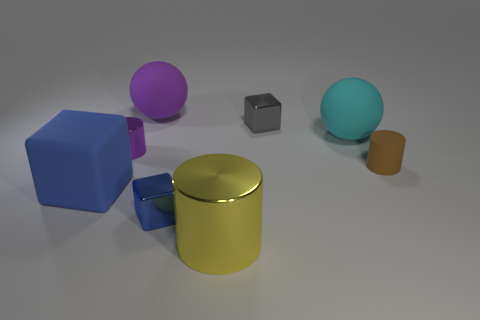What number of things are the same color as the large block?
Ensure brevity in your answer.  1. The small object that is to the right of the large matte object right of the tiny object that is behind the purple cylinder is what color?
Your response must be concise. Brown. What number of metal objects are blue blocks or small cyan cylinders?
Provide a succinct answer. 1. Are there more tiny blue cubes behind the big rubber cube than blue rubber things on the right side of the matte cylinder?
Offer a terse response. No. How many other objects are the same size as the purple rubber object?
Provide a short and direct response. 3. There is a shiny cube that is on the left side of the tiny metallic object that is behind the small metallic cylinder; what size is it?
Ensure brevity in your answer.  Small. How many tiny objects are either yellow metal cylinders or spheres?
Make the answer very short. 0. What size is the metallic object that is right of the metallic cylinder that is in front of the small cylinder that is right of the tiny purple thing?
Provide a succinct answer. Small. Is there any other thing of the same color as the large shiny cylinder?
Make the answer very short. No. There is a big object in front of the matte object to the left of the small object left of the big purple rubber sphere; what is it made of?
Provide a short and direct response. Metal. 